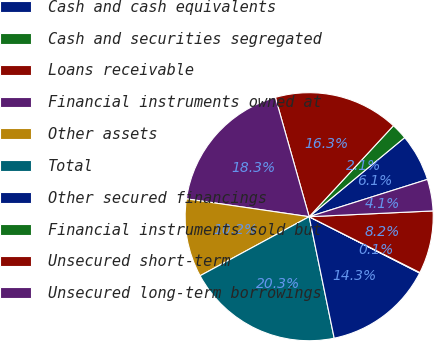Convert chart to OTSL. <chart><loc_0><loc_0><loc_500><loc_500><pie_chart><fcel>Cash and cash equivalents<fcel>Cash and securities segregated<fcel>Loans receivable<fcel>Financial instruments owned at<fcel>Other assets<fcel>Total<fcel>Other secured financings<fcel>Financial instruments sold but<fcel>Unsecured short-term<fcel>Unsecured long-term borrowings<nl><fcel>6.15%<fcel>2.1%<fcel>16.28%<fcel>18.31%<fcel>10.2%<fcel>20.34%<fcel>14.26%<fcel>0.07%<fcel>8.18%<fcel>4.12%<nl></chart> 